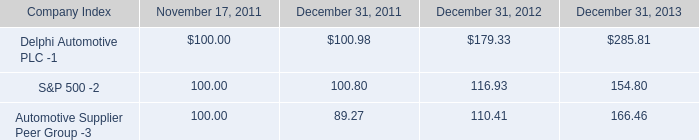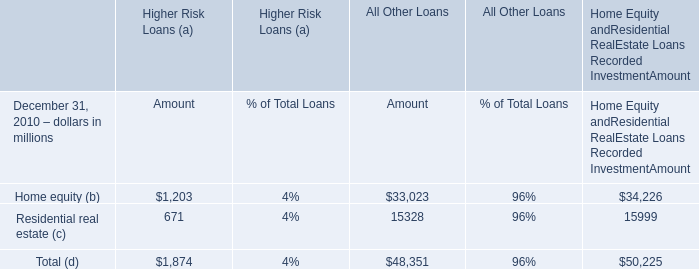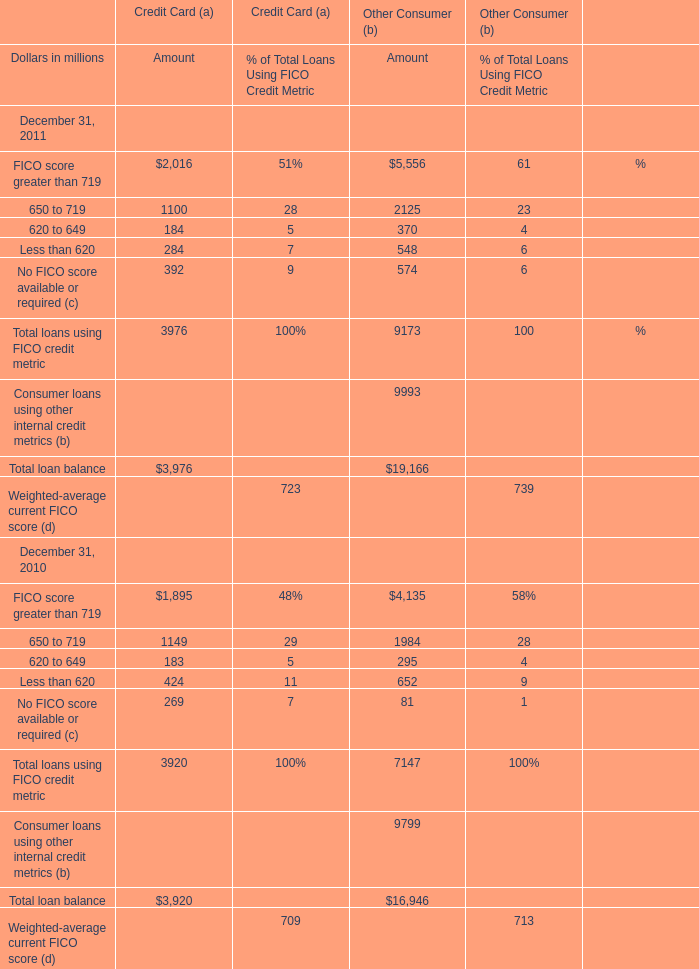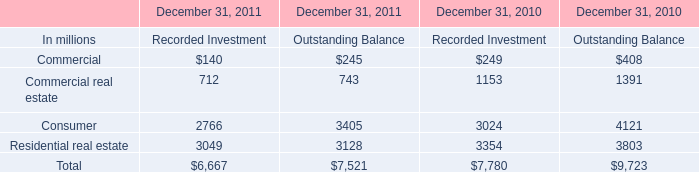What's the 20 % of total elements for Higher Risk Loans (a) of Amout in 2010? (in million) 
Computations: (1874 * 0.2)
Answer: 374.8. 